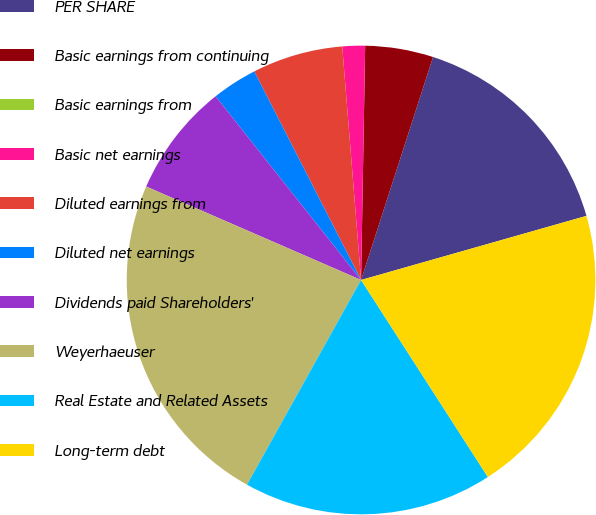<chart> <loc_0><loc_0><loc_500><loc_500><pie_chart><fcel>PER SHARE<fcel>Basic earnings from continuing<fcel>Basic earnings from<fcel>Basic net earnings<fcel>Diluted earnings from<fcel>Diluted net earnings<fcel>Dividends paid Shareholders'<fcel>Weyerhaeuser<fcel>Real Estate and Related Assets<fcel>Long-term debt<nl><fcel>15.62%<fcel>4.69%<fcel>0.0%<fcel>1.56%<fcel>6.25%<fcel>3.13%<fcel>7.81%<fcel>23.44%<fcel>17.19%<fcel>20.31%<nl></chart> 